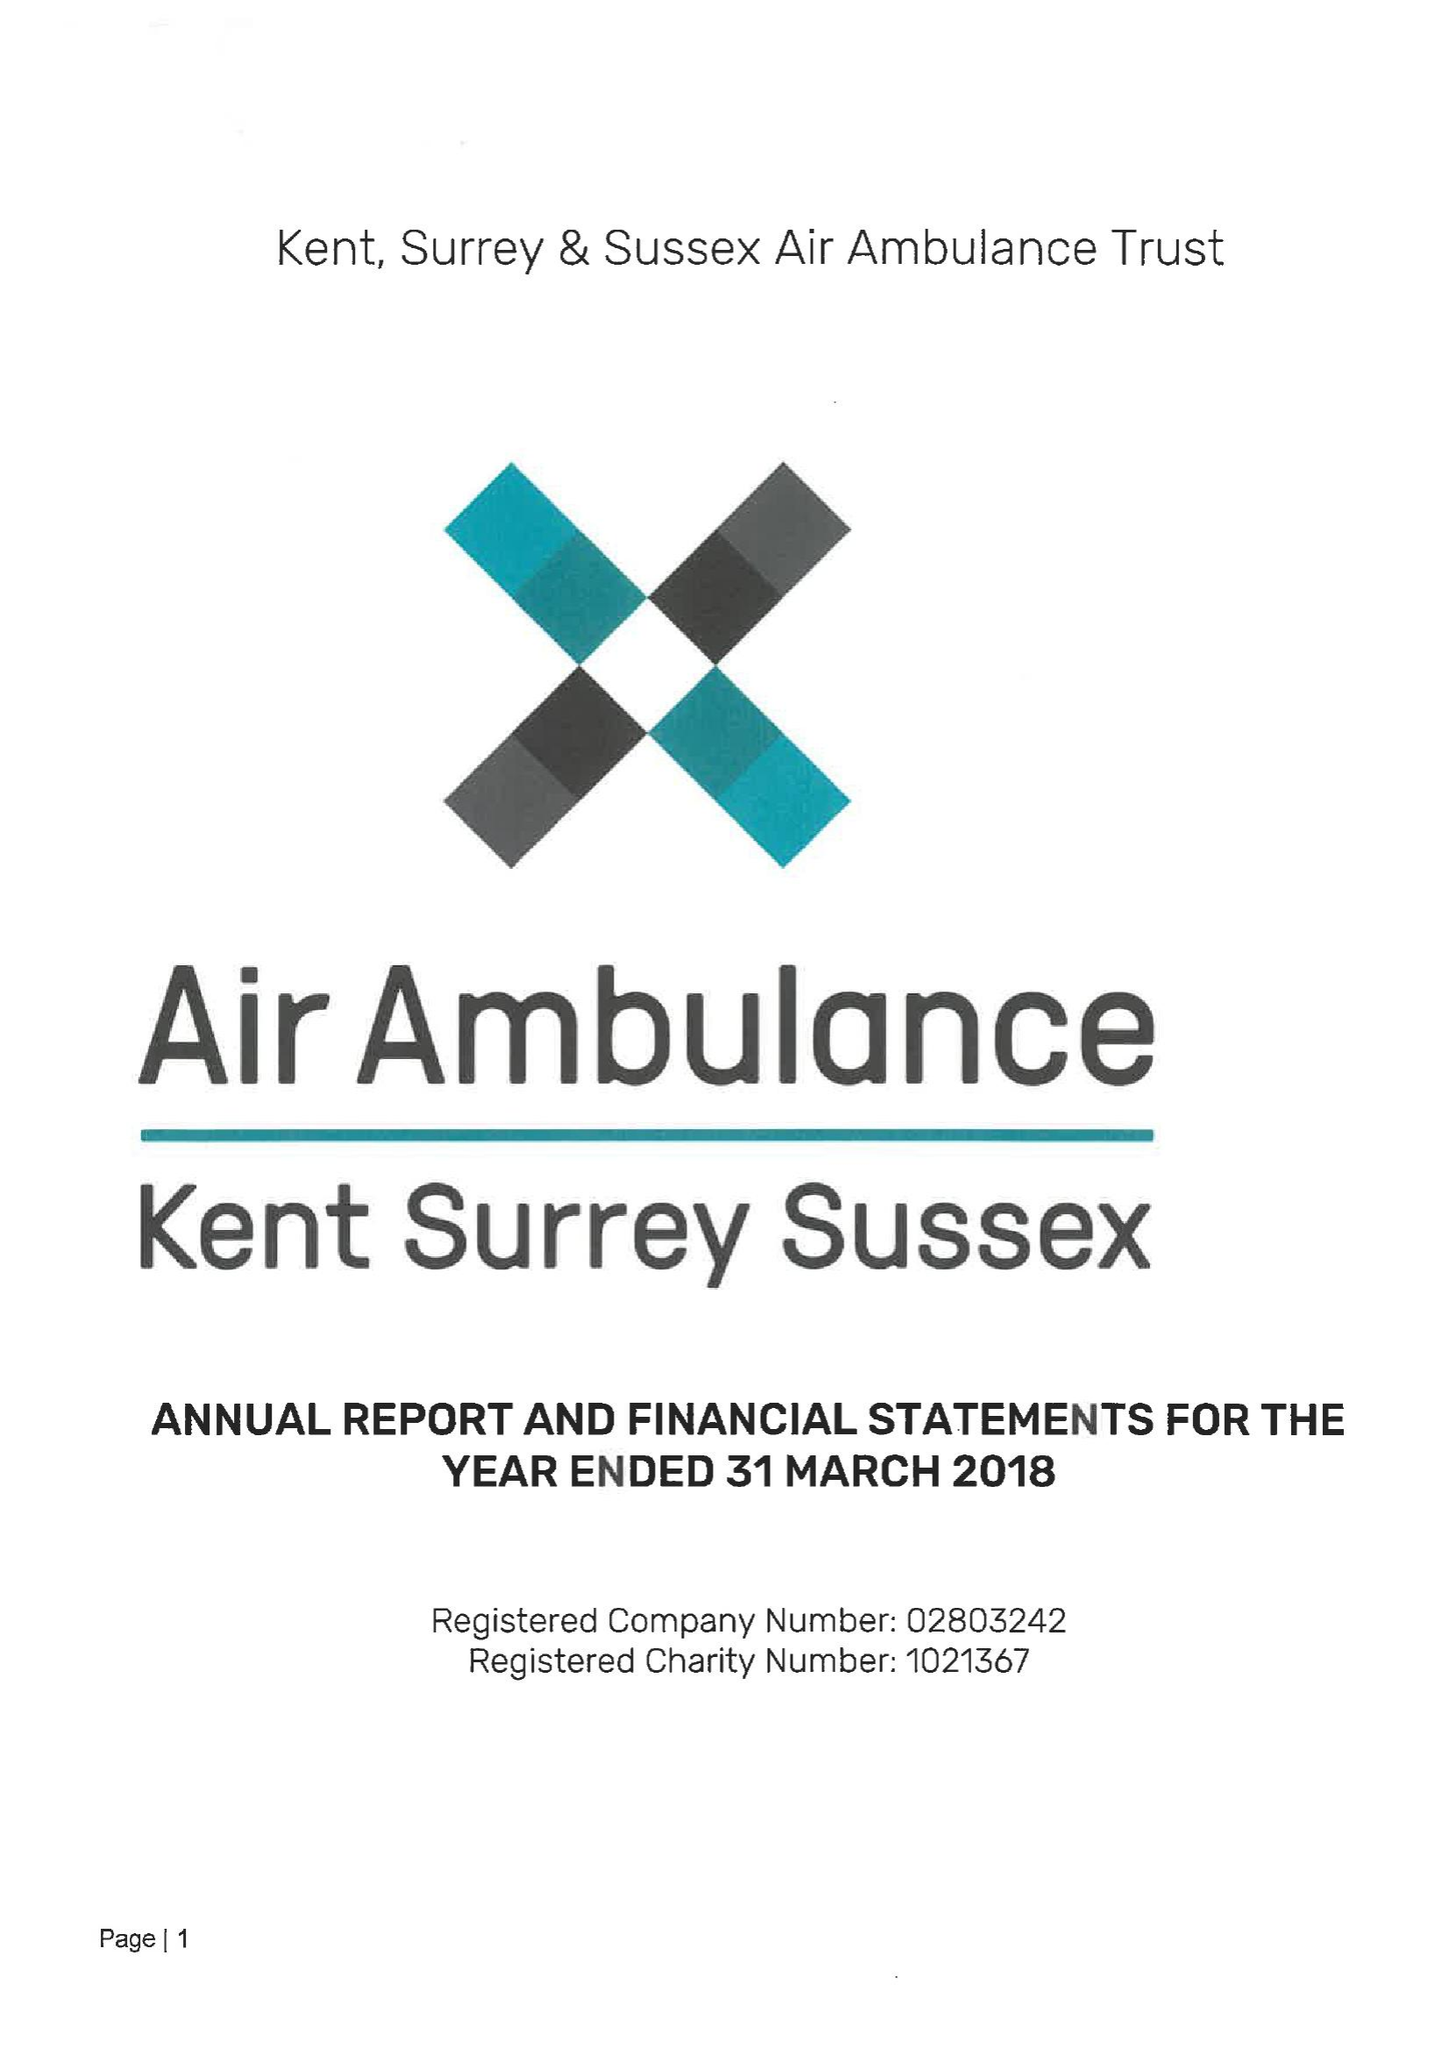What is the value for the charity_number?
Answer the question using a single word or phrase. 1021367 